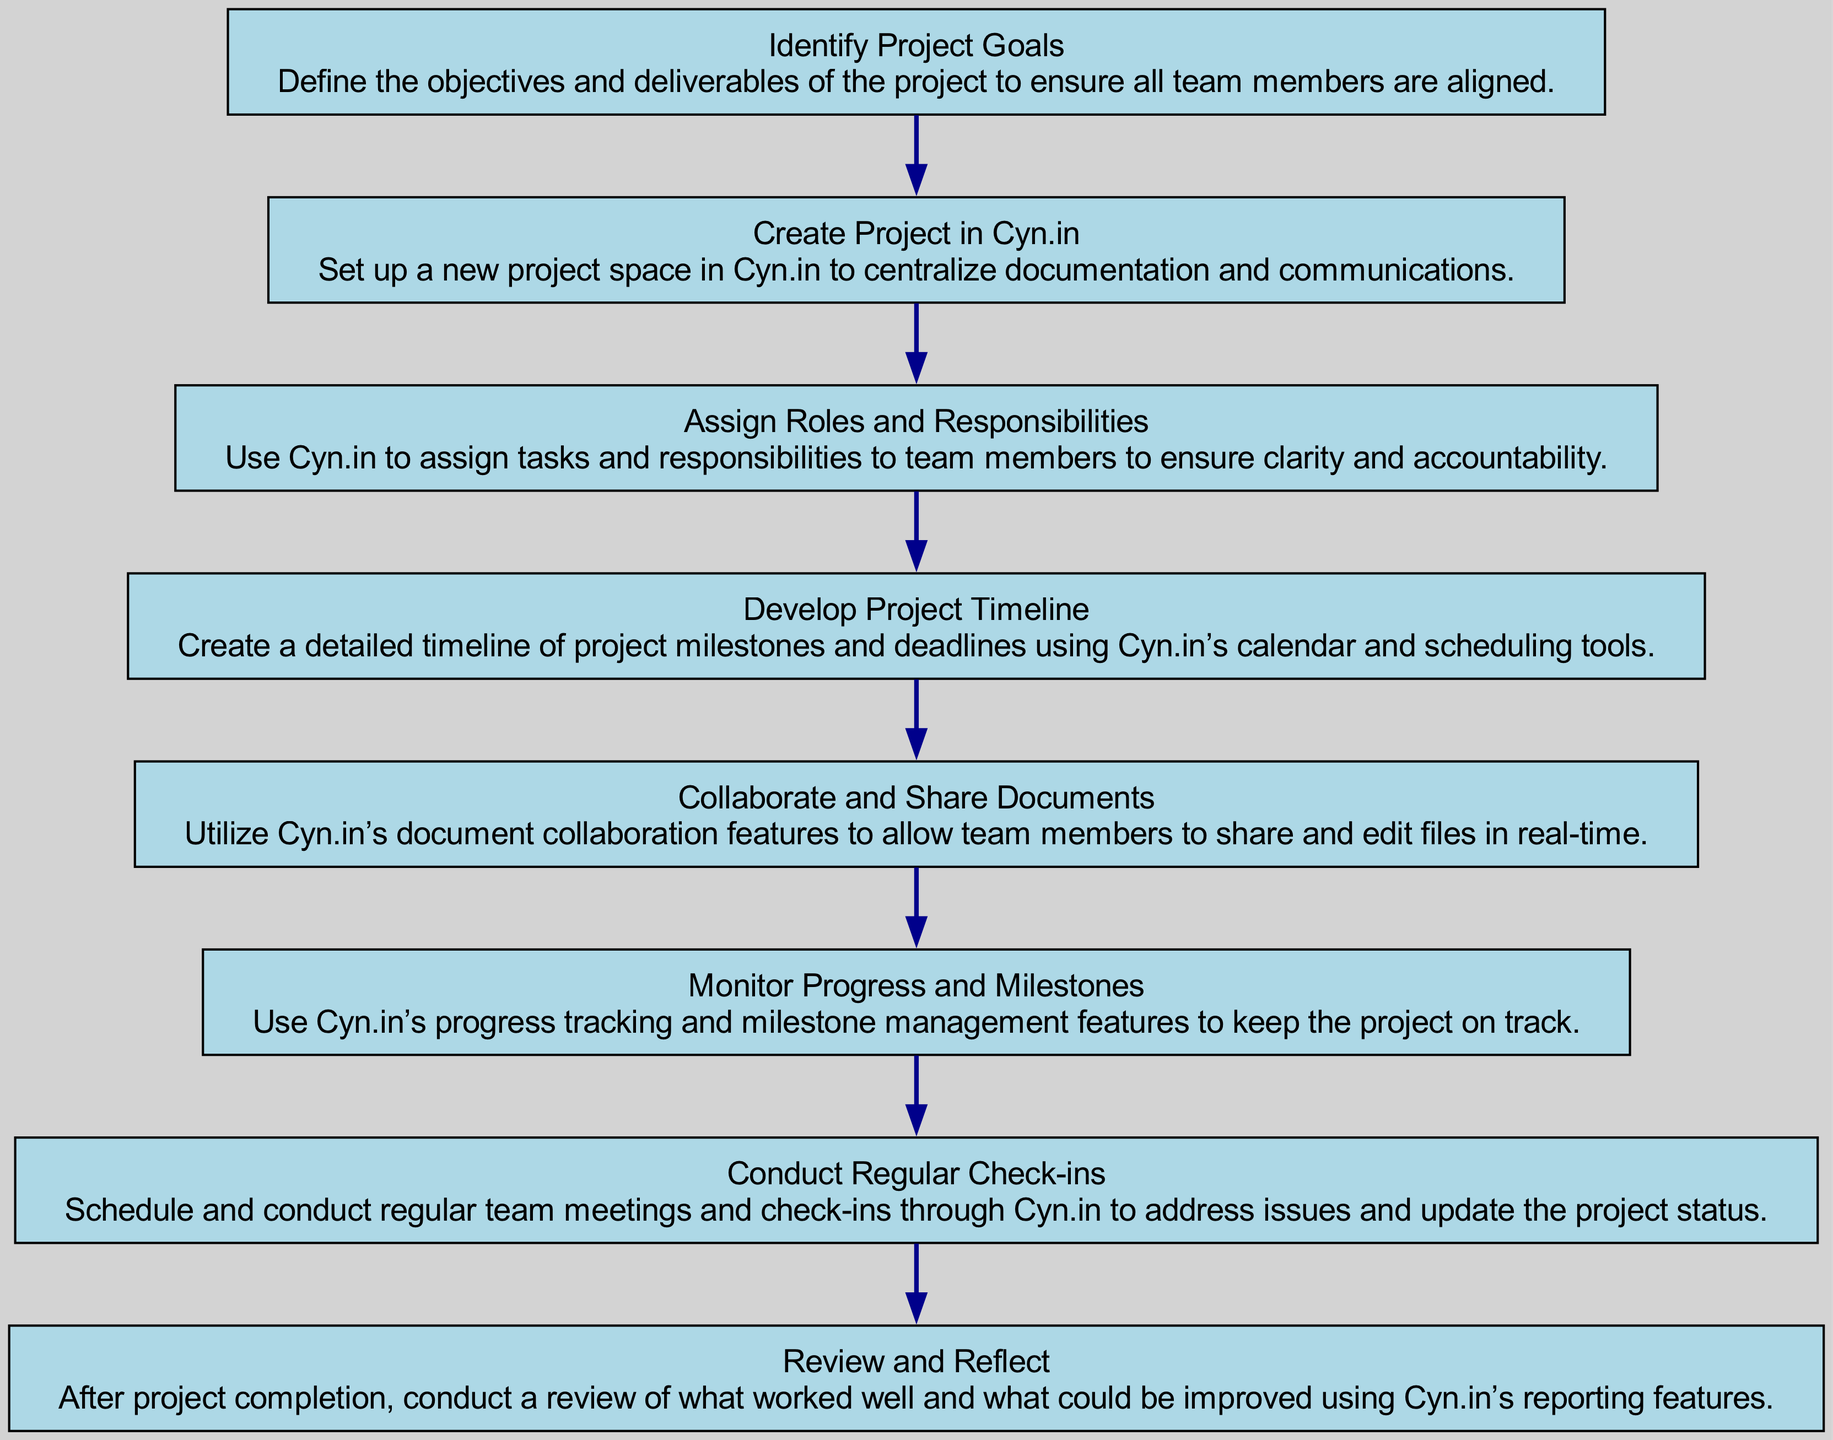What is the first step in the project management flow? The first step is "Identify Project Goals," which is the initial node in the flow chart, representing the starting point of the project management process.
Answer: Identify Project Goals How many total elements are present in the diagram? The diagram contains 8 elements, as listed in the provided data under the "elements" key.
Answer: 8 Which step follows after "Create Project in Cyn.in"? After "Create Project in Cyn.in," the next step in the flow chart is "Assign Roles and Responsibilities," which is directly connected to the previous node as the next action.
Answer: Assign Roles and Responsibilities What is the last step listed in the project management process? The last step is "Review and Reflect," which is the final element in the flow representing completion of the project and the analysis of outcomes.
Answer: Review and Reflect Which tool is used to centralize documentation and communications according to the flow chart? The flow chart specifies that "Cyn.in" is used to centralize documentation and communications, as indicated in the "Create Project in Cyn.in" node.
Answer: Cyn.in What is the primary purpose of the "Monitor Progress and Milestones" step? The step "Monitor Progress and Milestones" focuses on tracking the project’s advancement and ensuring it remains on schedule, as stated in its description.
Answer: Tracking progress How many steps require conducting meetings or check-ins? The flow chart indicates that there is one step requiring meetings, which is "Conduct Regular Check-ins," emphasizing the importance of team communication.
Answer: 1 What action is recommended before conducting "Review and Reflect"? It is recommended to complete all prior steps leading up to "Review and Reflect" to ensure a comprehensive assessment of the project outcomes, mainly including milestones and progress tracking aspects.
Answer: Complete all steps What feature is suggested for sharing and editing documents? The diagram suggests utilizing "Cyn.in’s document collaboration features" for sharing and editing files collaboratively among team members in real-time.
Answer: Document collaboration features 